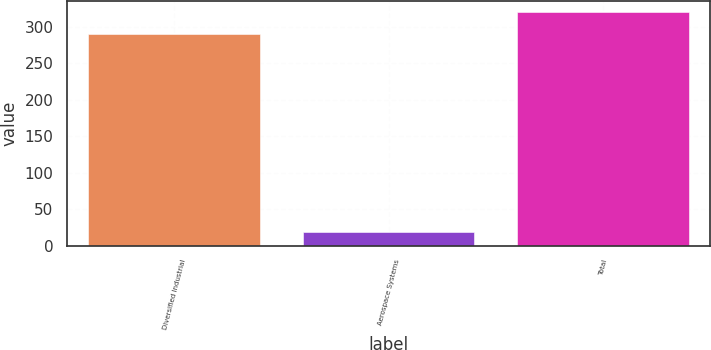Convert chart. <chart><loc_0><loc_0><loc_500><loc_500><bar_chart><fcel>Diversified Industrial<fcel>Aerospace Systems<fcel>Total<nl><fcel>291<fcel>19<fcel>320.1<nl></chart> 